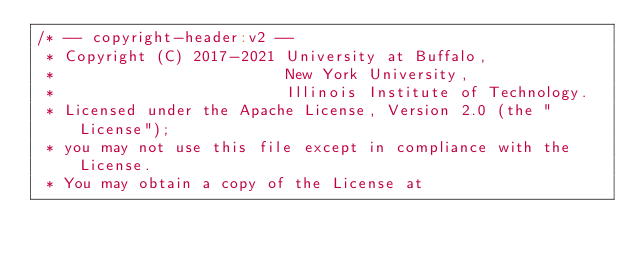Convert code to text. <code><loc_0><loc_0><loc_500><loc_500><_Scala_>/* -- copyright-header:v2 --
 * Copyright (C) 2017-2021 University at Buffalo,
 *                         New York University,
 *                         Illinois Institute of Technology.
 * Licensed under the Apache License, Version 2.0 (the "License");
 * you may not use this file except in compliance with the License.
 * You may obtain a copy of the License at</code> 